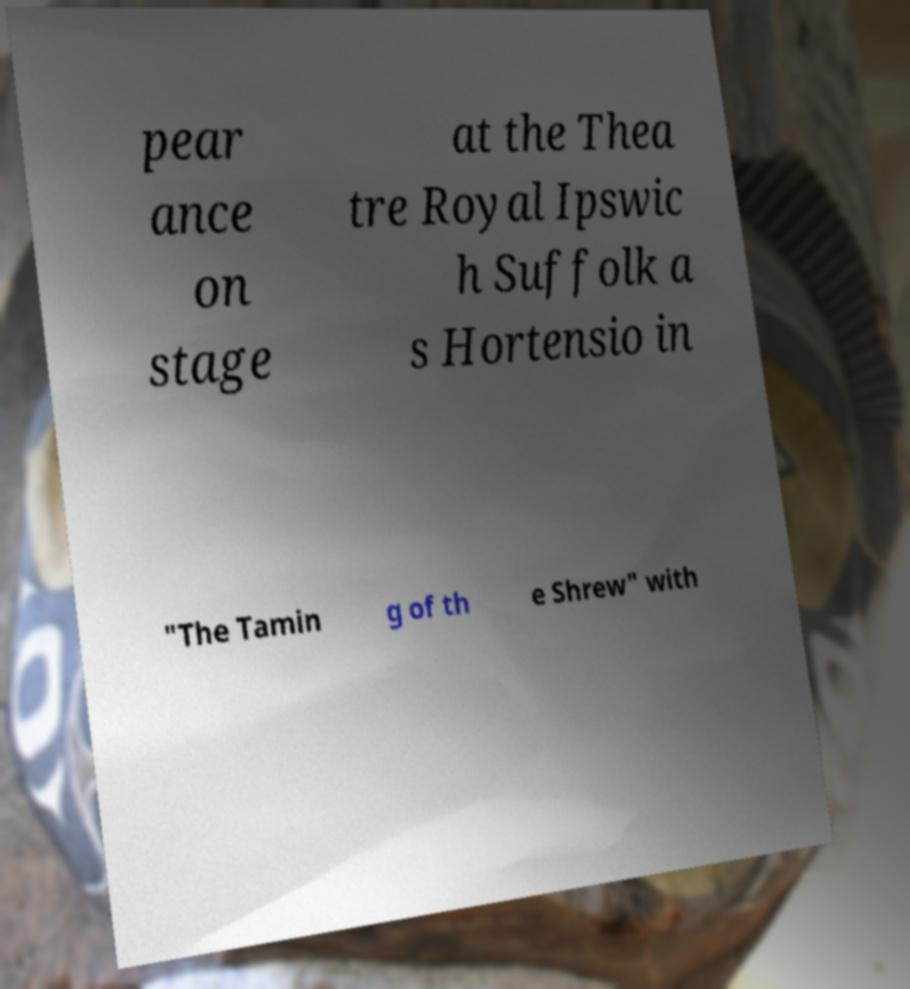For documentation purposes, I need the text within this image transcribed. Could you provide that? pear ance on stage at the Thea tre Royal Ipswic h Suffolk a s Hortensio in "The Tamin g of th e Shrew" with 